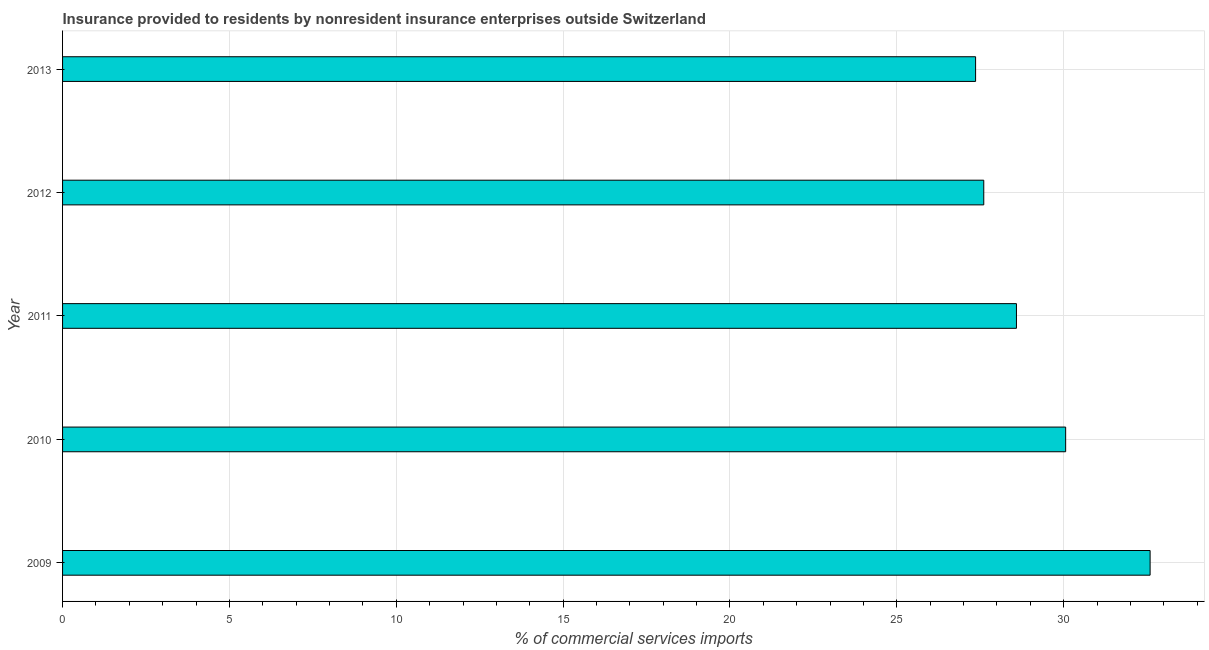Does the graph contain any zero values?
Make the answer very short. No. What is the title of the graph?
Your answer should be compact. Insurance provided to residents by nonresident insurance enterprises outside Switzerland. What is the label or title of the X-axis?
Your response must be concise. % of commercial services imports. What is the insurance provided by non-residents in 2009?
Provide a succinct answer. 32.59. Across all years, what is the maximum insurance provided by non-residents?
Give a very brief answer. 32.59. Across all years, what is the minimum insurance provided by non-residents?
Ensure brevity in your answer.  27.36. In which year was the insurance provided by non-residents maximum?
Your response must be concise. 2009. In which year was the insurance provided by non-residents minimum?
Offer a terse response. 2013. What is the sum of the insurance provided by non-residents?
Provide a short and direct response. 146.2. What is the difference between the insurance provided by non-residents in 2010 and 2012?
Keep it short and to the point. 2.45. What is the average insurance provided by non-residents per year?
Your answer should be very brief. 29.24. What is the median insurance provided by non-residents?
Ensure brevity in your answer.  28.58. In how many years, is the insurance provided by non-residents greater than 8 %?
Offer a very short reply. 5. What is the ratio of the insurance provided by non-residents in 2009 to that in 2011?
Give a very brief answer. 1.14. Is the insurance provided by non-residents in 2009 less than that in 2013?
Make the answer very short. No. What is the difference between the highest and the second highest insurance provided by non-residents?
Your answer should be very brief. 2.53. What is the difference between the highest and the lowest insurance provided by non-residents?
Provide a short and direct response. 5.23. Are all the bars in the graph horizontal?
Provide a short and direct response. Yes. How many years are there in the graph?
Your response must be concise. 5. Are the values on the major ticks of X-axis written in scientific E-notation?
Provide a short and direct response. No. What is the % of commercial services imports of 2009?
Make the answer very short. 32.59. What is the % of commercial services imports of 2010?
Provide a succinct answer. 30.06. What is the % of commercial services imports in 2011?
Ensure brevity in your answer.  28.58. What is the % of commercial services imports in 2012?
Provide a succinct answer. 27.6. What is the % of commercial services imports of 2013?
Ensure brevity in your answer.  27.36. What is the difference between the % of commercial services imports in 2009 and 2010?
Provide a succinct answer. 2.53. What is the difference between the % of commercial services imports in 2009 and 2011?
Your answer should be compact. 4.01. What is the difference between the % of commercial services imports in 2009 and 2012?
Offer a terse response. 4.98. What is the difference between the % of commercial services imports in 2009 and 2013?
Offer a terse response. 5.23. What is the difference between the % of commercial services imports in 2010 and 2011?
Your answer should be compact. 1.47. What is the difference between the % of commercial services imports in 2010 and 2012?
Ensure brevity in your answer.  2.45. What is the difference between the % of commercial services imports in 2010 and 2013?
Ensure brevity in your answer.  2.7. What is the difference between the % of commercial services imports in 2011 and 2012?
Make the answer very short. 0.98. What is the difference between the % of commercial services imports in 2011 and 2013?
Your answer should be compact. 1.22. What is the difference between the % of commercial services imports in 2012 and 2013?
Give a very brief answer. 0.24. What is the ratio of the % of commercial services imports in 2009 to that in 2010?
Offer a terse response. 1.08. What is the ratio of the % of commercial services imports in 2009 to that in 2011?
Offer a terse response. 1.14. What is the ratio of the % of commercial services imports in 2009 to that in 2012?
Offer a terse response. 1.18. What is the ratio of the % of commercial services imports in 2009 to that in 2013?
Keep it short and to the point. 1.19. What is the ratio of the % of commercial services imports in 2010 to that in 2011?
Your answer should be very brief. 1.05. What is the ratio of the % of commercial services imports in 2010 to that in 2012?
Offer a very short reply. 1.09. What is the ratio of the % of commercial services imports in 2010 to that in 2013?
Provide a short and direct response. 1.1. What is the ratio of the % of commercial services imports in 2011 to that in 2012?
Offer a terse response. 1.03. What is the ratio of the % of commercial services imports in 2011 to that in 2013?
Provide a succinct answer. 1.04. 